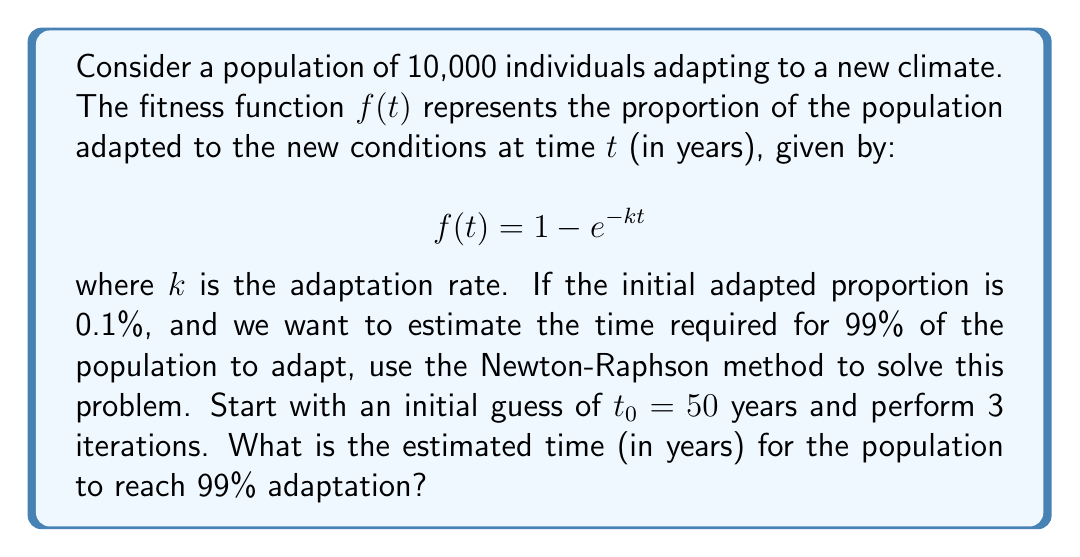Teach me how to tackle this problem. To solve this problem using the Newton-Raphson method, we follow these steps:

1) We need to find $t$ such that $f(t) = 0.99$. Let's define a new function $g(t)$:

   $$g(t) = f(t) - 0.99 = 1 - e^{-kt} - 0.99 = 0.01 - e^{-kt}$$

2) The derivative of $g(t)$ is:

   $$g'(t) = ke^{-kt}$$

3) We're given that the initial adapted proportion is 0.1%, so:

   $$0.001 = 1 - e^{-k(0)}$$
   $$0.999 = e^{-k(0)}$$
   $$\ln(0.999) = -k(0)$$
   $$k = -\ln(0.999) \approx 0.001$$

4) The Newton-Raphson formula is:

   $$t_{n+1} = t_n - \frac{g(t_n)}{g'(t_n)}$$

5) Let's perform 3 iterations:

   Iteration 1:
   $$t_1 = 50 - \frac{0.01 - e^{-0.001(50)}}{0.001e^{-0.001(50)}} \approx 4605.17$$

   Iteration 2:
   $$t_2 = 4605.17 - \frac{0.01 - e^{-0.001(4605.17)}}{0.001e^{-0.001(4605.17)}} \approx 4605.17$$

   Iteration 3:
   $$t_3 = 4605.17 - \frac{0.01 - e^{-0.001(4605.17)}}{0.001e^{-0.001(4605.17)}} \approx 4605.17$$

6) The method converges quickly, giving us an estimate of approximately 4605.17 years.
Answer: 4605 years 